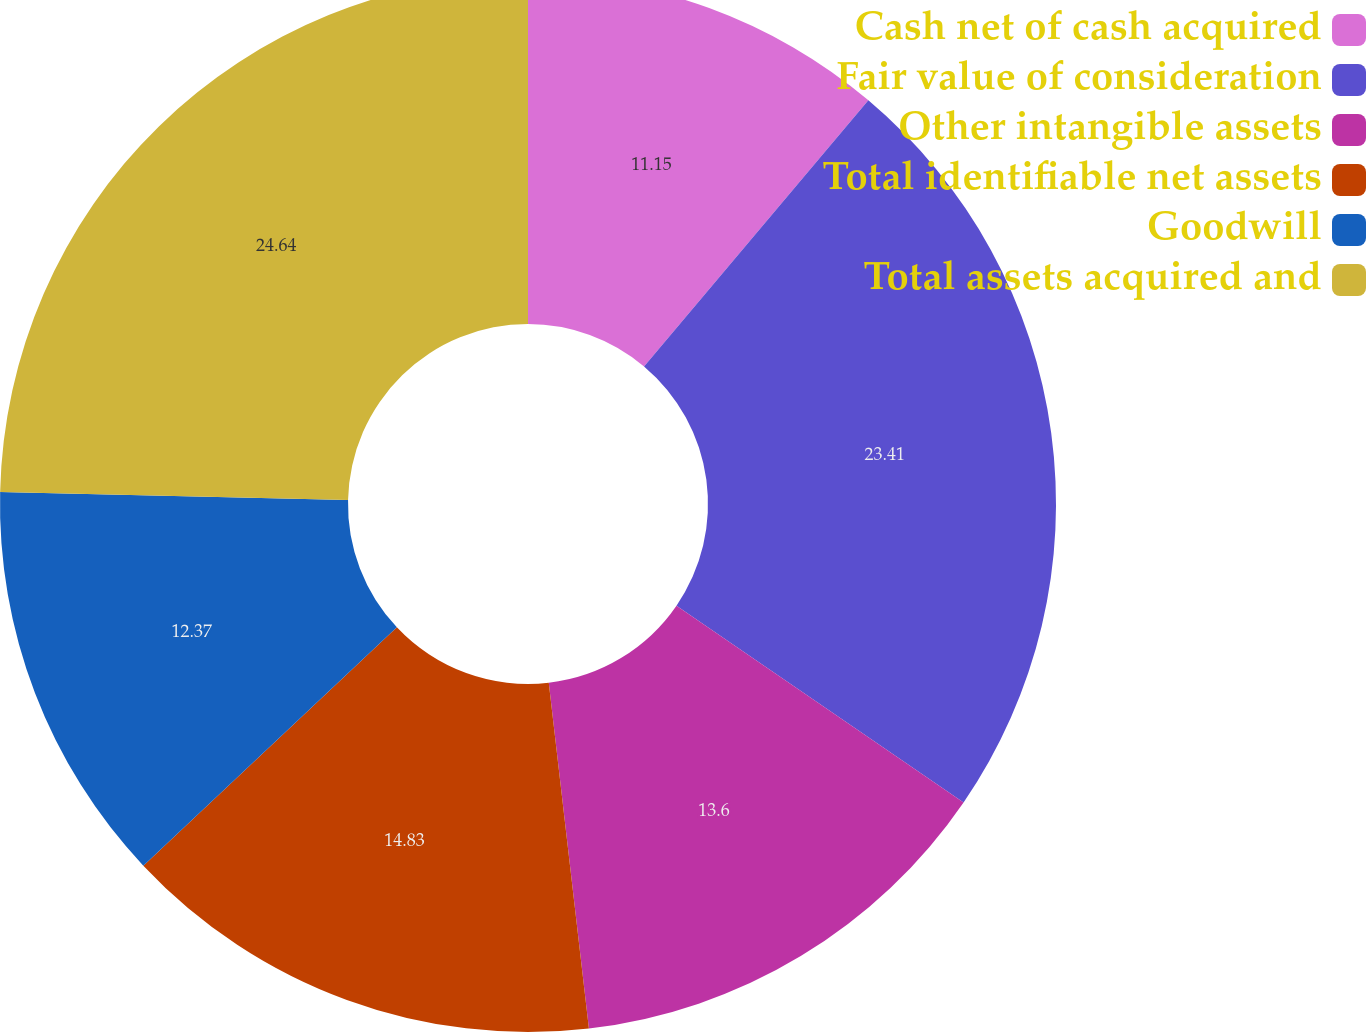<chart> <loc_0><loc_0><loc_500><loc_500><pie_chart><fcel>Cash net of cash acquired<fcel>Fair value of consideration<fcel>Other intangible assets<fcel>Total identifiable net assets<fcel>Goodwill<fcel>Total assets acquired and<nl><fcel>11.15%<fcel>23.41%<fcel>13.6%<fcel>14.83%<fcel>12.37%<fcel>24.64%<nl></chart> 